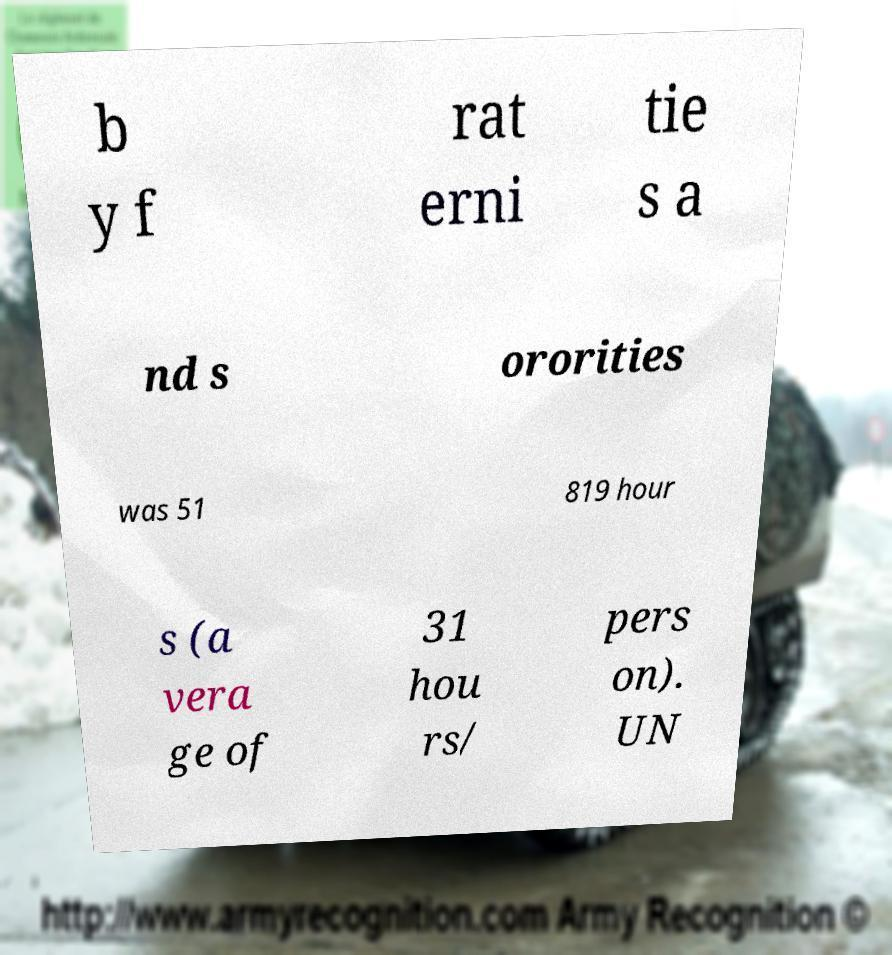What messages or text are displayed in this image? I need them in a readable, typed format. b y f rat erni tie s a nd s ororities was 51 819 hour s (a vera ge of 31 hou rs/ pers on). UN 